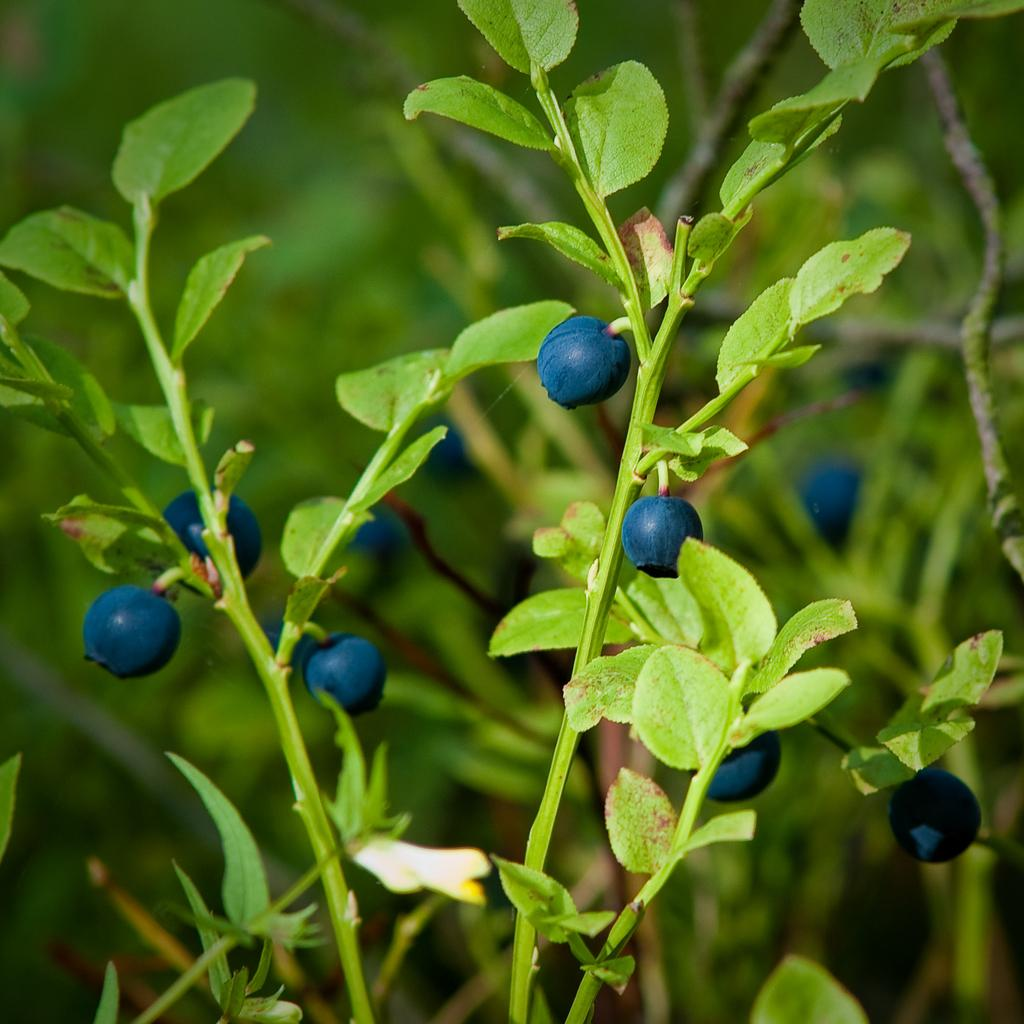What is located in the foreground of the image? There are berries in the foreground of the image. What are the berries resting on? The berries are on plants. What type of quince is being used as a balloon in the image? There is no quince or balloon present in the image; it features berries on plants. 